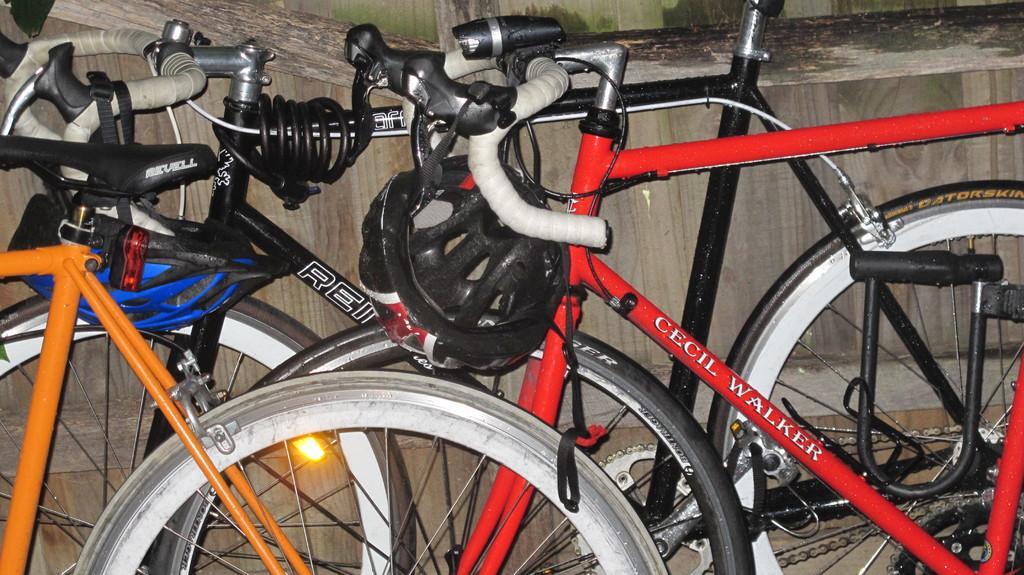Can you describe this image briefly? In the picture we can see some cycles which are placed near the wall some are red, black and orange in color and helmet to the handle which is black in color. 